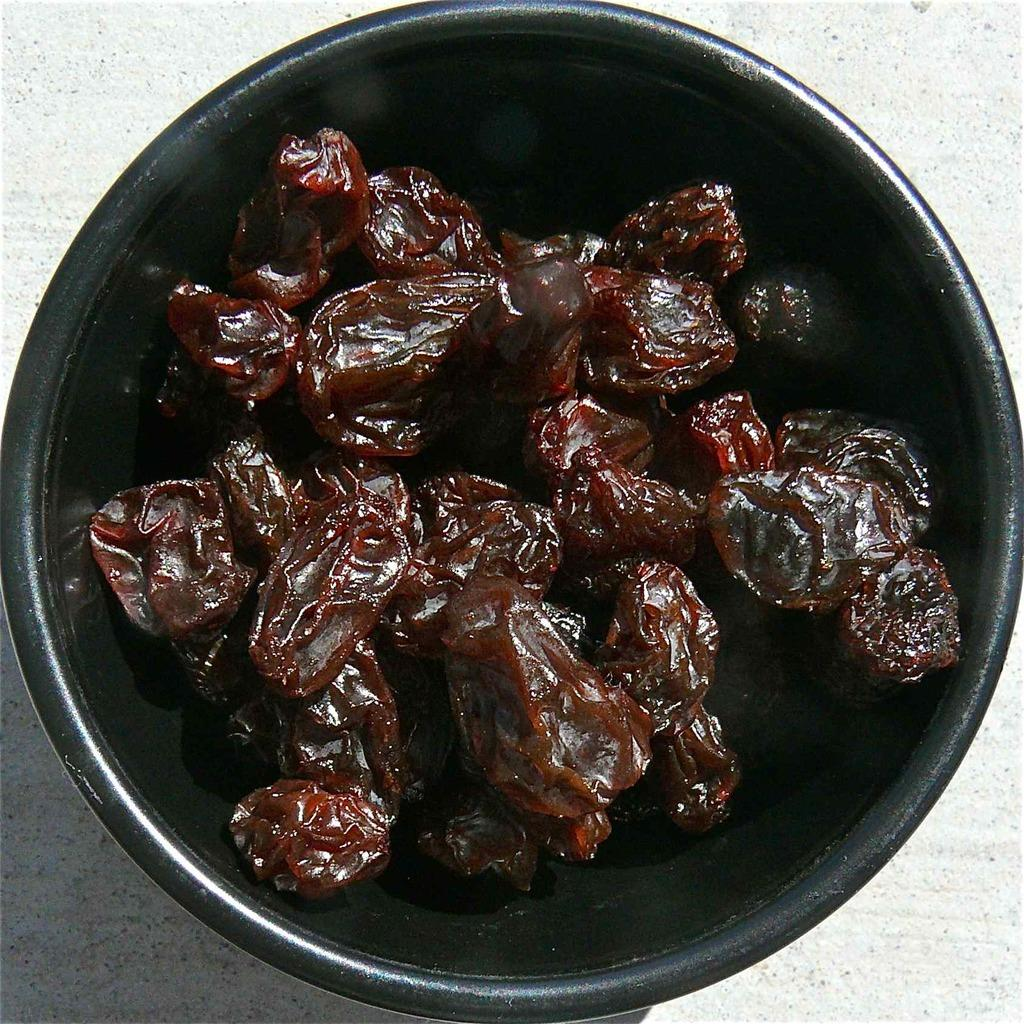What is in the bowl that is visible in the image? There is food in a bowl in the image. What is the color of the surface on which the bowl is placed? The bowl is placed on a white surface. Can you see any spots on the food in the image? There is no mention of spots on the food in the image, so it cannot be determined from the provided facts. 